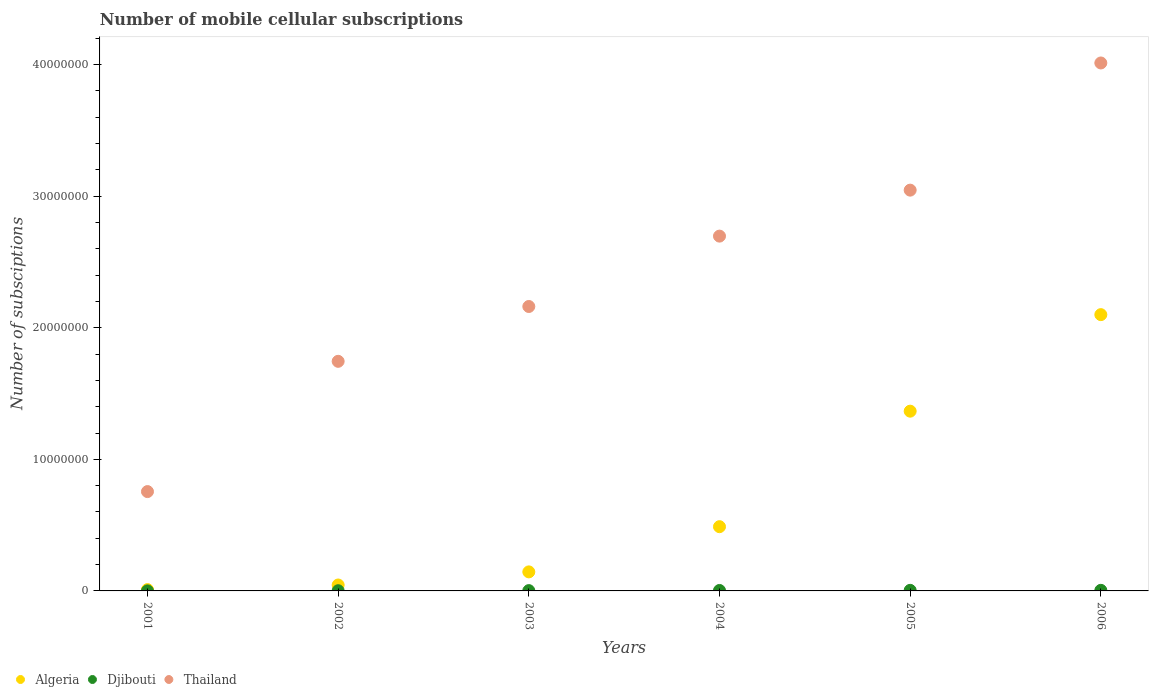Is the number of dotlines equal to the number of legend labels?
Provide a succinct answer. Yes. What is the number of mobile cellular subscriptions in Djibouti in 2002?
Provide a short and direct response. 1.50e+04. Across all years, what is the maximum number of mobile cellular subscriptions in Djibouti?
Ensure brevity in your answer.  4.48e+04. Across all years, what is the minimum number of mobile cellular subscriptions in Djibouti?
Provide a short and direct response. 3000. What is the total number of mobile cellular subscriptions in Algeria in the graph?
Your answer should be very brief. 4.15e+07. What is the difference between the number of mobile cellular subscriptions in Thailand in 2002 and that in 2006?
Your answer should be very brief. -2.27e+07. What is the difference between the number of mobile cellular subscriptions in Algeria in 2006 and the number of mobile cellular subscriptions in Thailand in 2001?
Make the answer very short. 1.34e+07. What is the average number of mobile cellular subscriptions in Djibouti per year?
Your response must be concise. 2.74e+04. In the year 2006, what is the difference between the number of mobile cellular subscriptions in Thailand and number of mobile cellular subscriptions in Algeria?
Keep it short and to the point. 1.91e+07. What is the ratio of the number of mobile cellular subscriptions in Djibouti in 2001 to that in 2003?
Provide a short and direct response. 0.13. What is the difference between the highest and the second highest number of mobile cellular subscriptions in Thailand?
Your answer should be very brief. 9.67e+06. What is the difference between the highest and the lowest number of mobile cellular subscriptions in Algeria?
Make the answer very short. 2.09e+07. In how many years, is the number of mobile cellular subscriptions in Algeria greater than the average number of mobile cellular subscriptions in Algeria taken over all years?
Keep it short and to the point. 2. Is the number of mobile cellular subscriptions in Thailand strictly greater than the number of mobile cellular subscriptions in Algeria over the years?
Ensure brevity in your answer.  Yes. How many dotlines are there?
Keep it short and to the point. 3. What is the difference between two consecutive major ticks on the Y-axis?
Keep it short and to the point. 1.00e+07. Are the values on the major ticks of Y-axis written in scientific E-notation?
Provide a short and direct response. No. How many legend labels are there?
Make the answer very short. 3. How are the legend labels stacked?
Provide a succinct answer. Horizontal. What is the title of the graph?
Offer a terse response. Number of mobile cellular subscriptions. What is the label or title of the Y-axis?
Your answer should be compact. Number of subsciptions. What is the Number of subsciptions in Djibouti in 2001?
Keep it short and to the point. 3000. What is the Number of subsciptions of Thailand in 2001?
Your answer should be very brief. 7.55e+06. What is the Number of subsciptions of Algeria in 2002?
Offer a very short reply. 4.50e+05. What is the Number of subsciptions in Djibouti in 2002?
Keep it short and to the point. 1.50e+04. What is the Number of subsciptions of Thailand in 2002?
Ensure brevity in your answer.  1.74e+07. What is the Number of subsciptions in Algeria in 2003?
Make the answer very short. 1.45e+06. What is the Number of subsciptions of Djibouti in 2003?
Make the answer very short. 2.30e+04. What is the Number of subsciptions of Thailand in 2003?
Your answer should be compact. 2.16e+07. What is the Number of subsciptions of Algeria in 2004?
Keep it short and to the point. 4.88e+06. What is the Number of subsciptions in Djibouti in 2004?
Provide a short and direct response. 3.45e+04. What is the Number of subsciptions in Thailand in 2004?
Your answer should be very brief. 2.70e+07. What is the Number of subsciptions of Algeria in 2005?
Your response must be concise. 1.37e+07. What is the Number of subsciptions in Djibouti in 2005?
Your response must be concise. 4.41e+04. What is the Number of subsciptions of Thailand in 2005?
Keep it short and to the point. 3.05e+07. What is the Number of subsciptions in Algeria in 2006?
Your answer should be compact. 2.10e+07. What is the Number of subsciptions of Djibouti in 2006?
Your answer should be very brief. 4.48e+04. What is the Number of subsciptions in Thailand in 2006?
Keep it short and to the point. 4.01e+07. Across all years, what is the maximum Number of subsciptions in Algeria?
Provide a succinct answer. 2.10e+07. Across all years, what is the maximum Number of subsciptions in Djibouti?
Give a very brief answer. 4.48e+04. Across all years, what is the maximum Number of subsciptions of Thailand?
Offer a terse response. 4.01e+07. Across all years, what is the minimum Number of subsciptions of Djibouti?
Your response must be concise. 3000. Across all years, what is the minimum Number of subsciptions of Thailand?
Your answer should be very brief. 7.55e+06. What is the total Number of subsciptions of Algeria in the graph?
Make the answer very short. 4.15e+07. What is the total Number of subsciptions of Djibouti in the graph?
Provide a succinct answer. 1.64e+05. What is the total Number of subsciptions of Thailand in the graph?
Your answer should be very brief. 1.44e+08. What is the difference between the Number of subsciptions of Algeria in 2001 and that in 2002?
Your response must be concise. -3.50e+05. What is the difference between the Number of subsciptions in Djibouti in 2001 and that in 2002?
Your response must be concise. -1.20e+04. What is the difference between the Number of subsciptions of Thailand in 2001 and that in 2002?
Ensure brevity in your answer.  -9.90e+06. What is the difference between the Number of subsciptions in Algeria in 2001 and that in 2003?
Make the answer very short. -1.35e+06. What is the difference between the Number of subsciptions of Djibouti in 2001 and that in 2003?
Provide a succinct answer. -2.00e+04. What is the difference between the Number of subsciptions of Thailand in 2001 and that in 2003?
Your response must be concise. -1.41e+07. What is the difference between the Number of subsciptions of Algeria in 2001 and that in 2004?
Your answer should be very brief. -4.78e+06. What is the difference between the Number of subsciptions of Djibouti in 2001 and that in 2004?
Offer a terse response. -3.15e+04. What is the difference between the Number of subsciptions of Thailand in 2001 and that in 2004?
Keep it short and to the point. -1.94e+07. What is the difference between the Number of subsciptions of Algeria in 2001 and that in 2005?
Ensure brevity in your answer.  -1.36e+07. What is the difference between the Number of subsciptions in Djibouti in 2001 and that in 2005?
Ensure brevity in your answer.  -4.11e+04. What is the difference between the Number of subsciptions in Thailand in 2001 and that in 2005?
Provide a short and direct response. -2.29e+07. What is the difference between the Number of subsciptions of Algeria in 2001 and that in 2006?
Your answer should be very brief. -2.09e+07. What is the difference between the Number of subsciptions in Djibouti in 2001 and that in 2006?
Give a very brief answer. -4.18e+04. What is the difference between the Number of subsciptions in Thailand in 2001 and that in 2006?
Provide a succinct answer. -3.26e+07. What is the difference between the Number of subsciptions of Algeria in 2002 and that in 2003?
Make the answer very short. -9.97e+05. What is the difference between the Number of subsciptions in Djibouti in 2002 and that in 2003?
Give a very brief answer. -8000. What is the difference between the Number of subsciptions of Thailand in 2002 and that in 2003?
Give a very brief answer. -4.17e+06. What is the difference between the Number of subsciptions of Algeria in 2002 and that in 2004?
Ensure brevity in your answer.  -4.43e+06. What is the difference between the Number of subsciptions of Djibouti in 2002 and that in 2004?
Ensure brevity in your answer.  -1.95e+04. What is the difference between the Number of subsciptions of Thailand in 2002 and that in 2004?
Your response must be concise. -9.52e+06. What is the difference between the Number of subsciptions in Algeria in 2002 and that in 2005?
Make the answer very short. -1.32e+07. What is the difference between the Number of subsciptions of Djibouti in 2002 and that in 2005?
Make the answer very short. -2.91e+04. What is the difference between the Number of subsciptions of Thailand in 2002 and that in 2005?
Your answer should be very brief. -1.30e+07. What is the difference between the Number of subsciptions of Algeria in 2002 and that in 2006?
Ensure brevity in your answer.  -2.05e+07. What is the difference between the Number of subsciptions in Djibouti in 2002 and that in 2006?
Keep it short and to the point. -2.98e+04. What is the difference between the Number of subsciptions of Thailand in 2002 and that in 2006?
Offer a terse response. -2.27e+07. What is the difference between the Number of subsciptions of Algeria in 2003 and that in 2004?
Ensure brevity in your answer.  -3.44e+06. What is the difference between the Number of subsciptions of Djibouti in 2003 and that in 2004?
Provide a short and direct response. -1.15e+04. What is the difference between the Number of subsciptions of Thailand in 2003 and that in 2004?
Your answer should be compact. -5.35e+06. What is the difference between the Number of subsciptions of Algeria in 2003 and that in 2005?
Your answer should be very brief. -1.22e+07. What is the difference between the Number of subsciptions in Djibouti in 2003 and that in 2005?
Offer a terse response. -2.11e+04. What is the difference between the Number of subsciptions of Thailand in 2003 and that in 2005?
Your answer should be compact. -8.84e+06. What is the difference between the Number of subsciptions of Algeria in 2003 and that in 2006?
Your response must be concise. -1.96e+07. What is the difference between the Number of subsciptions in Djibouti in 2003 and that in 2006?
Offer a very short reply. -2.18e+04. What is the difference between the Number of subsciptions of Thailand in 2003 and that in 2006?
Ensure brevity in your answer.  -1.85e+07. What is the difference between the Number of subsciptions of Algeria in 2004 and that in 2005?
Offer a very short reply. -8.78e+06. What is the difference between the Number of subsciptions of Djibouti in 2004 and that in 2005?
Keep it short and to the point. -9571. What is the difference between the Number of subsciptions in Thailand in 2004 and that in 2005?
Your answer should be very brief. -3.49e+06. What is the difference between the Number of subsciptions of Algeria in 2004 and that in 2006?
Give a very brief answer. -1.61e+07. What is the difference between the Number of subsciptions of Djibouti in 2004 and that in 2006?
Give a very brief answer. -1.03e+04. What is the difference between the Number of subsciptions in Thailand in 2004 and that in 2006?
Give a very brief answer. -1.32e+07. What is the difference between the Number of subsciptions in Algeria in 2005 and that in 2006?
Your response must be concise. -7.34e+06. What is the difference between the Number of subsciptions in Djibouti in 2005 and that in 2006?
Give a very brief answer. -764. What is the difference between the Number of subsciptions of Thailand in 2005 and that in 2006?
Give a very brief answer. -9.67e+06. What is the difference between the Number of subsciptions of Algeria in 2001 and the Number of subsciptions of Djibouti in 2002?
Provide a short and direct response. 8.50e+04. What is the difference between the Number of subsciptions in Algeria in 2001 and the Number of subsciptions in Thailand in 2002?
Provide a succinct answer. -1.73e+07. What is the difference between the Number of subsciptions of Djibouti in 2001 and the Number of subsciptions of Thailand in 2002?
Offer a very short reply. -1.74e+07. What is the difference between the Number of subsciptions in Algeria in 2001 and the Number of subsciptions in Djibouti in 2003?
Ensure brevity in your answer.  7.70e+04. What is the difference between the Number of subsciptions in Algeria in 2001 and the Number of subsciptions in Thailand in 2003?
Provide a short and direct response. -2.15e+07. What is the difference between the Number of subsciptions of Djibouti in 2001 and the Number of subsciptions of Thailand in 2003?
Provide a succinct answer. -2.16e+07. What is the difference between the Number of subsciptions in Algeria in 2001 and the Number of subsciptions in Djibouti in 2004?
Offer a terse response. 6.55e+04. What is the difference between the Number of subsciptions in Algeria in 2001 and the Number of subsciptions in Thailand in 2004?
Make the answer very short. -2.69e+07. What is the difference between the Number of subsciptions of Djibouti in 2001 and the Number of subsciptions of Thailand in 2004?
Offer a very short reply. -2.70e+07. What is the difference between the Number of subsciptions of Algeria in 2001 and the Number of subsciptions of Djibouti in 2005?
Provide a succinct answer. 5.59e+04. What is the difference between the Number of subsciptions in Algeria in 2001 and the Number of subsciptions in Thailand in 2005?
Keep it short and to the point. -3.04e+07. What is the difference between the Number of subsciptions in Djibouti in 2001 and the Number of subsciptions in Thailand in 2005?
Offer a very short reply. -3.05e+07. What is the difference between the Number of subsciptions in Algeria in 2001 and the Number of subsciptions in Djibouti in 2006?
Your answer should be compact. 5.52e+04. What is the difference between the Number of subsciptions in Algeria in 2001 and the Number of subsciptions in Thailand in 2006?
Offer a very short reply. -4.00e+07. What is the difference between the Number of subsciptions of Djibouti in 2001 and the Number of subsciptions of Thailand in 2006?
Provide a short and direct response. -4.01e+07. What is the difference between the Number of subsciptions in Algeria in 2002 and the Number of subsciptions in Djibouti in 2003?
Offer a very short reply. 4.27e+05. What is the difference between the Number of subsciptions in Algeria in 2002 and the Number of subsciptions in Thailand in 2003?
Provide a short and direct response. -2.12e+07. What is the difference between the Number of subsciptions of Djibouti in 2002 and the Number of subsciptions of Thailand in 2003?
Give a very brief answer. -2.16e+07. What is the difference between the Number of subsciptions in Algeria in 2002 and the Number of subsciptions in Djibouti in 2004?
Offer a terse response. 4.16e+05. What is the difference between the Number of subsciptions in Algeria in 2002 and the Number of subsciptions in Thailand in 2004?
Offer a very short reply. -2.65e+07. What is the difference between the Number of subsciptions of Djibouti in 2002 and the Number of subsciptions of Thailand in 2004?
Keep it short and to the point. -2.70e+07. What is the difference between the Number of subsciptions of Algeria in 2002 and the Number of subsciptions of Djibouti in 2005?
Your response must be concise. 4.06e+05. What is the difference between the Number of subsciptions of Algeria in 2002 and the Number of subsciptions of Thailand in 2005?
Provide a succinct answer. -3.00e+07. What is the difference between the Number of subsciptions of Djibouti in 2002 and the Number of subsciptions of Thailand in 2005?
Provide a succinct answer. -3.04e+07. What is the difference between the Number of subsciptions in Algeria in 2002 and the Number of subsciptions in Djibouti in 2006?
Provide a succinct answer. 4.05e+05. What is the difference between the Number of subsciptions in Algeria in 2002 and the Number of subsciptions in Thailand in 2006?
Make the answer very short. -3.97e+07. What is the difference between the Number of subsciptions of Djibouti in 2002 and the Number of subsciptions of Thailand in 2006?
Offer a terse response. -4.01e+07. What is the difference between the Number of subsciptions of Algeria in 2003 and the Number of subsciptions of Djibouti in 2004?
Your response must be concise. 1.41e+06. What is the difference between the Number of subsciptions of Algeria in 2003 and the Number of subsciptions of Thailand in 2004?
Offer a very short reply. -2.55e+07. What is the difference between the Number of subsciptions of Djibouti in 2003 and the Number of subsciptions of Thailand in 2004?
Provide a short and direct response. -2.69e+07. What is the difference between the Number of subsciptions in Algeria in 2003 and the Number of subsciptions in Djibouti in 2005?
Provide a succinct answer. 1.40e+06. What is the difference between the Number of subsciptions of Algeria in 2003 and the Number of subsciptions of Thailand in 2005?
Provide a short and direct response. -2.90e+07. What is the difference between the Number of subsciptions in Djibouti in 2003 and the Number of subsciptions in Thailand in 2005?
Ensure brevity in your answer.  -3.04e+07. What is the difference between the Number of subsciptions in Algeria in 2003 and the Number of subsciptions in Djibouti in 2006?
Keep it short and to the point. 1.40e+06. What is the difference between the Number of subsciptions of Algeria in 2003 and the Number of subsciptions of Thailand in 2006?
Your response must be concise. -3.87e+07. What is the difference between the Number of subsciptions of Djibouti in 2003 and the Number of subsciptions of Thailand in 2006?
Offer a very short reply. -4.01e+07. What is the difference between the Number of subsciptions in Algeria in 2004 and the Number of subsciptions in Djibouti in 2005?
Your answer should be compact. 4.84e+06. What is the difference between the Number of subsciptions of Algeria in 2004 and the Number of subsciptions of Thailand in 2005?
Your answer should be very brief. -2.56e+07. What is the difference between the Number of subsciptions in Djibouti in 2004 and the Number of subsciptions in Thailand in 2005?
Your response must be concise. -3.04e+07. What is the difference between the Number of subsciptions in Algeria in 2004 and the Number of subsciptions in Djibouti in 2006?
Ensure brevity in your answer.  4.84e+06. What is the difference between the Number of subsciptions in Algeria in 2004 and the Number of subsciptions in Thailand in 2006?
Your answer should be very brief. -3.52e+07. What is the difference between the Number of subsciptions of Djibouti in 2004 and the Number of subsciptions of Thailand in 2006?
Offer a very short reply. -4.01e+07. What is the difference between the Number of subsciptions of Algeria in 2005 and the Number of subsciptions of Djibouti in 2006?
Your answer should be very brief. 1.36e+07. What is the difference between the Number of subsciptions of Algeria in 2005 and the Number of subsciptions of Thailand in 2006?
Your response must be concise. -2.65e+07. What is the difference between the Number of subsciptions of Djibouti in 2005 and the Number of subsciptions of Thailand in 2006?
Your answer should be very brief. -4.01e+07. What is the average Number of subsciptions in Algeria per year?
Your response must be concise. 6.92e+06. What is the average Number of subsciptions of Djibouti per year?
Make the answer very short. 2.74e+04. What is the average Number of subsciptions of Thailand per year?
Provide a short and direct response. 2.40e+07. In the year 2001, what is the difference between the Number of subsciptions in Algeria and Number of subsciptions in Djibouti?
Offer a terse response. 9.70e+04. In the year 2001, what is the difference between the Number of subsciptions of Algeria and Number of subsciptions of Thailand?
Provide a succinct answer. -7.45e+06. In the year 2001, what is the difference between the Number of subsciptions in Djibouti and Number of subsciptions in Thailand?
Offer a terse response. -7.55e+06. In the year 2002, what is the difference between the Number of subsciptions of Algeria and Number of subsciptions of Djibouti?
Give a very brief answer. 4.35e+05. In the year 2002, what is the difference between the Number of subsciptions in Algeria and Number of subsciptions in Thailand?
Your answer should be very brief. -1.70e+07. In the year 2002, what is the difference between the Number of subsciptions of Djibouti and Number of subsciptions of Thailand?
Give a very brief answer. -1.74e+07. In the year 2003, what is the difference between the Number of subsciptions in Algeria and Number of subsciptions in Djibouti?
Your response must be concise. 1.42e+06. In the year 2003, what is the difference between the Number of subsciptions in Algeria and Number of subsciptions in Thailand?
Your answer should be compact. -2.02e+07. In the year 2003, what is the difference between the Number of subsciptions of Djibouti and Number of subsciptions of Thailand?
Provide a short and direct response. -2.16e+07. In the year 2004, what is the difference between the Number of subsciptions in Algeria and Number of subsciptions in Djibouti?
Give a very brief answer. 4.85e+06. In the year 2004, what is the difference between the Number of subsciptions of Algeria and Number of subsciptions of Thailand?
Your response must be concise. -2.21e+07. In the year 2004, what is the difference between the Number of subsciptions in Djibouti and Number of subsciptions in Thailand?
Make the answer very short. -2.69e+07. In the year 2005, what is the difference between the Number of subsciptions in Algeria and Number of subsciptions in Djibouti?
Provide a short and direct response. 1.36e+07. In the year 2005, what is the difference between the Number of subsciptions of Algeria and Number of subsciptions of Thailand?
Your response must be concise. -1.68e+07. In the year 2005, what is the difference between the Number of subsciptions of Djibouti and Number of subsciptions of Thailand?
Your answer should be very brief. -3.04e+07. In the year 2006, what is the difference between the Number of subsciptions of Algeria and Number of subsciptions of Djibouti?
Ensure brevity in your answer.  2.10e+07. In the year 2006, what is the difference between the Number of subsciptions in Algeria and Number of subsciptions in Thailand?
Make the answer very short. -1.91e+07. In the year 2006, what is the difference between the Number of subsciptions of Djibouti and Number of subsciptions of Thailand?
Ensure brevity in your answer.  -4.01e+07. What is the ratio of the Number of subsciptions of Algeria in 2001 to that in 2002?
Your answer should be very brief. 0.22. What is the ratio of the Number of subsciptions of Thailand in 2001 to that in 2002?
Provide a short and direct response. 0.43. What is the ratio of the Number of subsciptions of Algeria in 2001 to that in 2003?
Ensure brevity in your answer.  0.07. What is the ratio of the Number of subsciptions in Djibouti in 2001 to that in 2003?
Offer a very short reply. 0.13. What is the ratio of the Number of subsciptions of Thailand in 2001 to that in 2003?
Your response must be concise. 0.35. What is the ratio of the Number of subsciptions of Algeria in 2001 to that in 2004?
Keep it short and to the point. 0.02. What is the ratio of the Number of subsciptions of Djibouti in 2001 to that in 2004?
Your answer should be compact. 0.09. What is the ratio of the Number of subsciptions in Thailand in 2001 to that in 2004?
Provide a short and direct response. 0.28. What is the ratio of the Number of subsciptions of Algeria in 2001 to that in 2005?
Keep it short and to the point. 0.01. What is the ratio of the Number of subsciptions of Djibouti in 2001 to that in 2005?
Provide a succinct answer. 0.07. What is the ratio of the Number of subsciptions of Thailand in 2001 to that in 2005?
Provide a succinct answer. 0.25. What is the ratio of the Number of subsciptions in Algeria in 2001 to that in 2006?
Your answer should be compact. 0. What is the ratio of the Number of subsciptions of Djibouti in 2001 to that in 2006?
Keep it short and to the point. 0.07. What is the ratio of the Number of subsciptions in Thailand in 2001 to that in 2006?
Provide a short and direct response. 0.19. What is the ratio of the Number of subsciptions of Algeria in 2002 to that in 2003?
Your answer should be very brief. 0.31. What is the ratio of the Number of subsciptions in Djibouti in 2002 to that in 2003?
Provide a succinct answer. 0.65. What is the ratio of the Number of subsciptions in Thailand in 2002 to that in 2003?
Give a very brief answer. 0.81. What is the ratio of the Number of subsciptions of Algeria in 2002 to that in 2004?
Offer a very short reply. 0.09. What is the ratio of the Number of subsciptions of Djibouti in 2002 to that in 2004?
Provide a short and direct response. 0.43. What is the ratio of the Number of subsciptions in Thailand in 2002 to that in 2004?
Your answer should be very brief. 0.65. What is the ratio of the Number of subsciptions of Algeria in 2002 to that in 2005?
Offer a very short reply. 0.03. What is the ratio of the Number of subsciptions in Djibouti in 2002 to that in 2005?
Keep it short and to the point. 0.34. What is the ratio of the Number of subsciptions of Thailand in 2002 to that in 2005?
Offer a very short reply. 0.57. What is the ratio of the Number of subsciptions in Algeria in 2002 to that in 2006?
Your response must be concise. 0.02. What is the ratio of the Number of subsciptions of Djibouti in 2002 to that in 2006?
Provide a short and direct response. 0.33. What is the ratio of the Number of subsciptions of Thailand in 2002 to that in 2006?
Your answer should be compact. 0.43. What is the ratio of the Number of subsciptions in Algeria in 2003 to that in 2004?
Give a very brief answer. 0.3. What is the ratio of the Number of subsciptions in Djibouti in 2003 to that in 2004?
Make the answer very short. 0.67. What is the ratio of the Number of subsciptions in Thailand in 2003 to that in 2004?
Provide a succinct answer. 0.8. What is the ratio of the Number of subsciptions in Algeria in 2003 to that in 2005?
Your answer should be compact. 0.11. What is the ratio of the Number of subsciptions in Djibouti in 2003 to that in 2005?
Give a very brief answer. 0.52. What is the ratio of the Number of subsciptions of Thailand in 2003 to that in 2005?
Your answer should be very brief. 0.71. What is the ratio of the Number of subsciptions in Algeria in 2003 to that in 2006?
Make the answer very short. 0.07. What is the ratio of the Number of subsciptions in Djibouti in 2003 to that in 2006?
Ensure brevity in your answer.  0.51. What is the ratio of the Number of subsciptions of Thailand in 2003 to that in 2006?
Make the answer very short. 0.54. What is the ratio of the Number of subsciptions of Algeria in 2004 to that in 2005?
Offer a terse response. 0.36. What is the ratio of the Number of subsciptions in Djibouti in 2004 to that in 2005?
Your answer should be compact. 0.78. What is the ratio of the Number of subsciptions in Thailand in 2004 to that in 2005?
Provide a succinct answer. 0.89. What is the ratio of the Number of subsciptions of Algeria in 2004 to that in 2006?
Offer a very short reply. 0.23. What is the ratio of the Number of subsciptions of Djibouti in 2004 to that in 2006?
Provide a short and direct response. 0.77. What is the ratio of the Number of subsciptions in Thailand in 2004 to that in 2006?
Keep it short and to the point. 0.67. What is the ratio of the Number of subsciptions in Algeria in 2005 to that in 2006?
Keep it short and to the point. 0.65. What is the ratio of the Number of subsciptions of Thailand in 2005 to that in 2006?
Offer a very short reply. 0.76. What is the difference between the highest and the second highest Number of subsciptions of Algeria?
Your response must be concise. 7.34e+06. What is the difference between the highest and the second highest Number of subsciptions of Djibouti?
Make the answer very short. 764. What is the difference between the highest and the second highest Number of subsciptions of Thailand?
Your answer should be compact. 9.67e+06. What is the difference between the highest and the lowest Number of subsciptions in Algeria?
Your answer should be very brief. 2.09e+07. What is the difference between the highest and the lowest Number of subsciptions in Djibouti?
Keep it short and to the point. 4.18e+04. What is the difference between the highest and the lowest Number of subsciptions in Thailand?
Offer a terse response. 3.26e+07. 